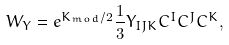Convert formula to latex. <formula><loc_0><loc_0><loc_500><loc_500>W _ { Y } = e ^ { K _ { m o d } / 2 } \frac { 1 } { 3 } Y _ { I J K } C ^ { I } C ^ { J } C ^ { K } ,</formula> 